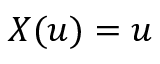Convert formula to latex. <formula><loc_0><loc_0><loc_500><loc_500>X ( u ) = u</formula> 